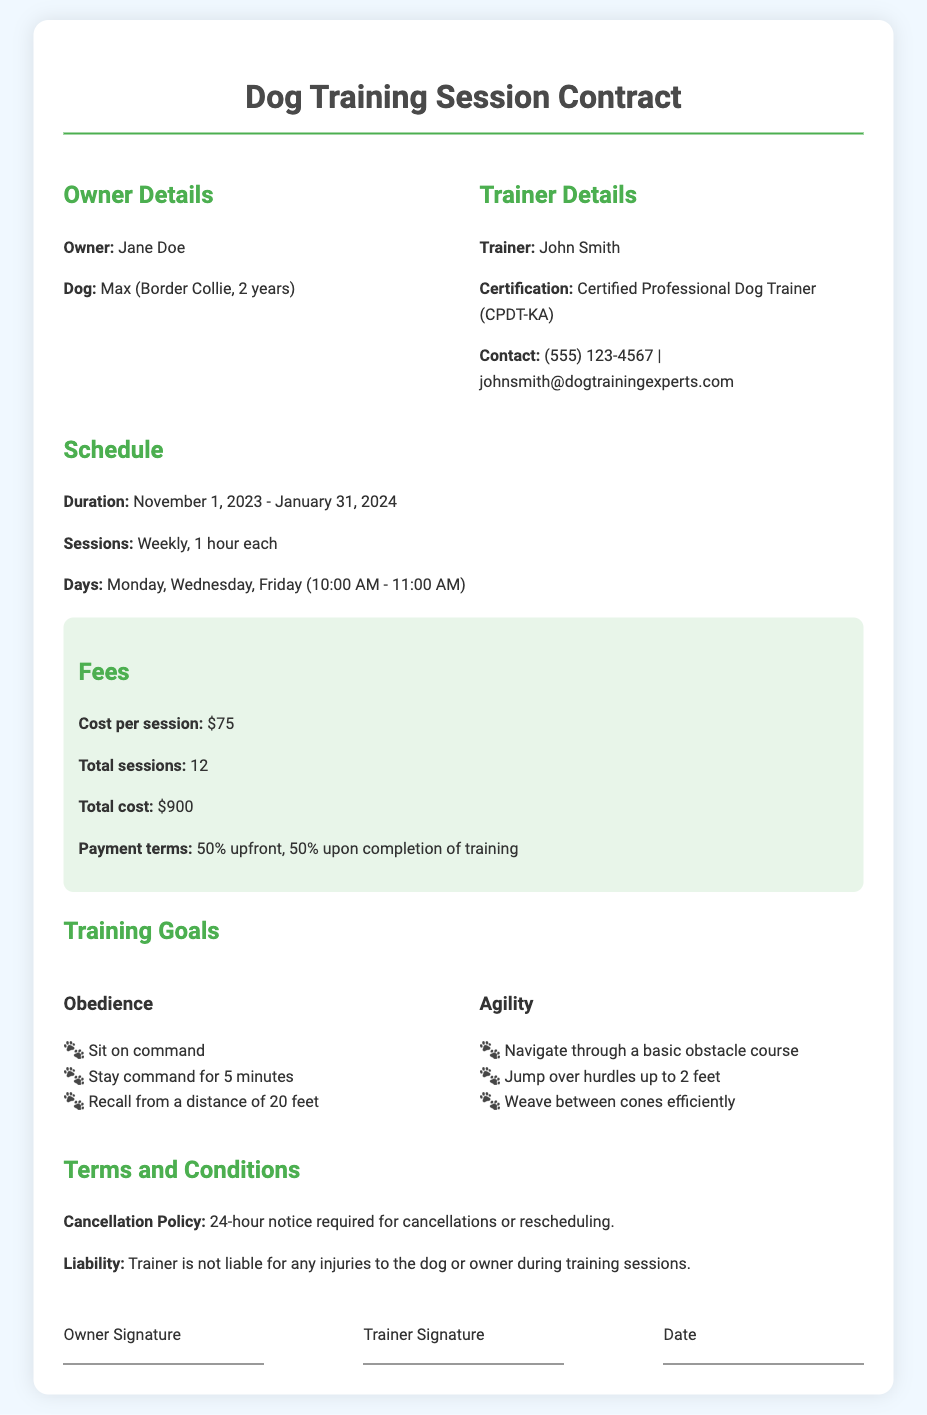what is the owner's name? The owner's name is specifically mentioned in the details section of the document.
Answer: Jane Doe how many total sessions are included? The total number of sessions is clearly stated in the fees section of the document.
Answer: 12 what is the cost per session? The cost per session can be found under the fees section of the document.
Answer: $75 what is the duration of the training sessions? The duration of the sessions is outlined in the schedule section of the document, indicating the start and end dates.
Answer: November 1, 2023 - January 31, 2024 what are the training goals for obedience? The document lists specific training goals for obedience, found in the training goals section.
Answer: Sit on command, Stay command for 5 minutes, Recall from a distance of 20 feet how often will training sessions occur? The frequency of the training sessions is specified within the schedule section of the document.
Answer: Weekly what is the cancellation policy? The cancellation policy is outlined in the terms and conditions section of the document.
Answer: 24-hour notice required what is the payment term? The payment terms are specifically mentioned in the fees section of the document, indicating how payments should be made.
Answer: 50% upfront, 50% upon completion of training 